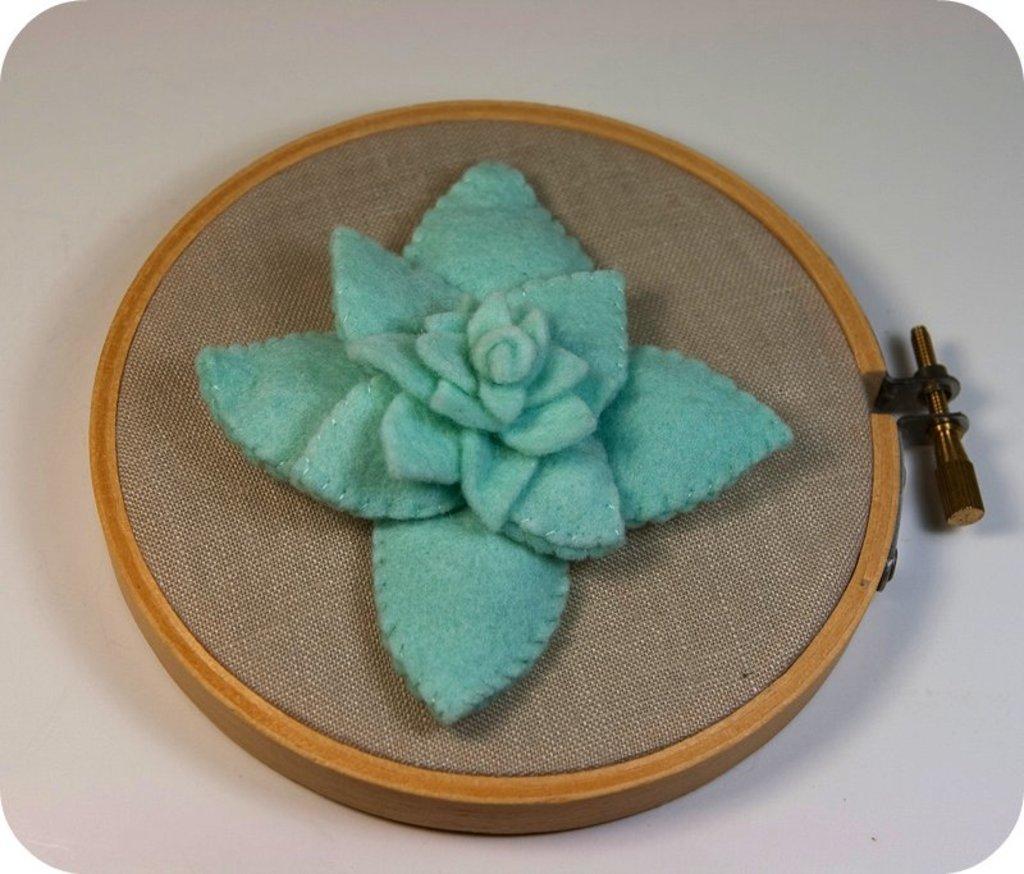Can you describe this image briefly? This picture seems to be an edited image with the borders. In the center we can see an object which seems to be the table on the top of which a wooden frame containing a cloth with a flower art and a screw is placed. 